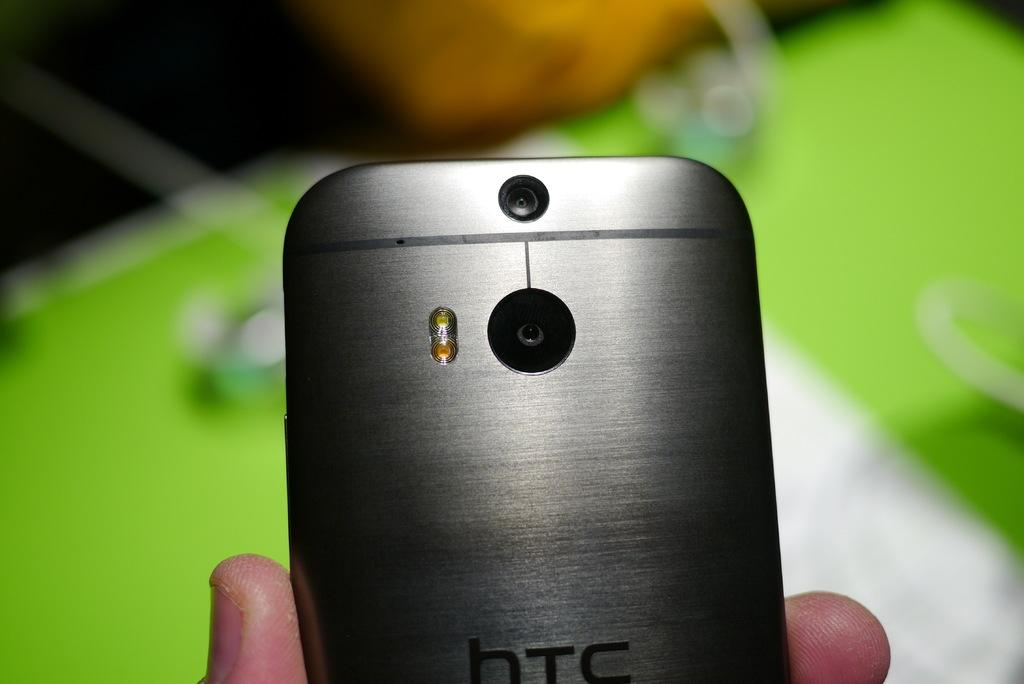<image>
Create a compact narrative representing the image presented. Someone is holding a silver HTC cell phone in their hand showing the camera lens. 